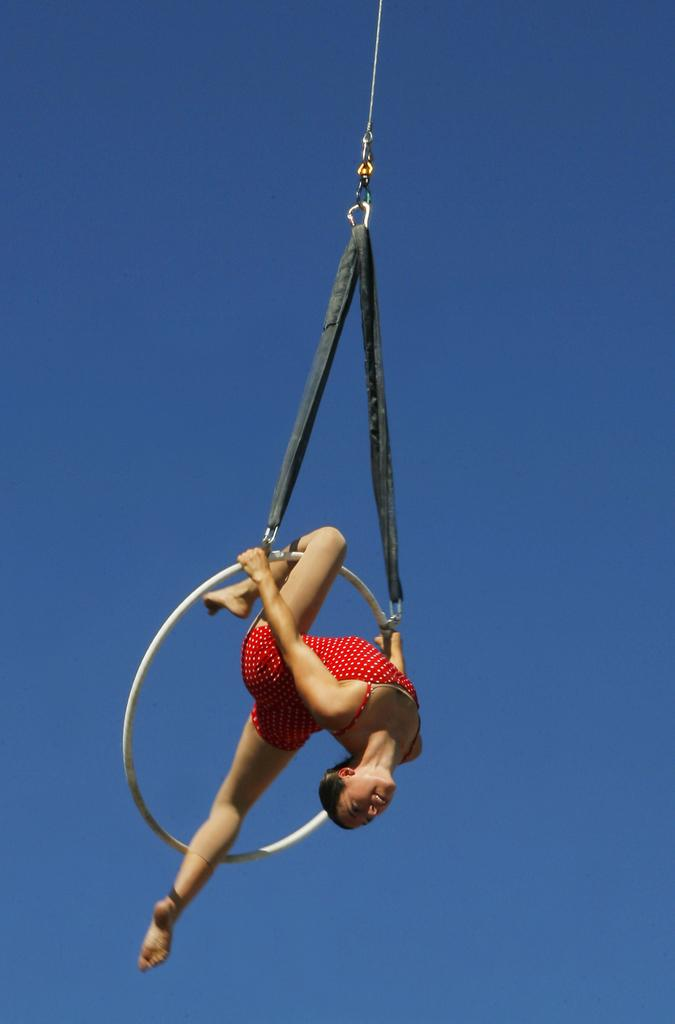What is the person in the image doing? The person is doing an aerial gymnast on a ring. What is the person wearing while performing the aerial gymnast? The person is wearing a red dress. Where is the writer sitting in the image? There is no writer present in the image; it features a person doing an aerial gymnast on a ring. Can you tell me how much money is visible in the image? There is no money present in the image. 